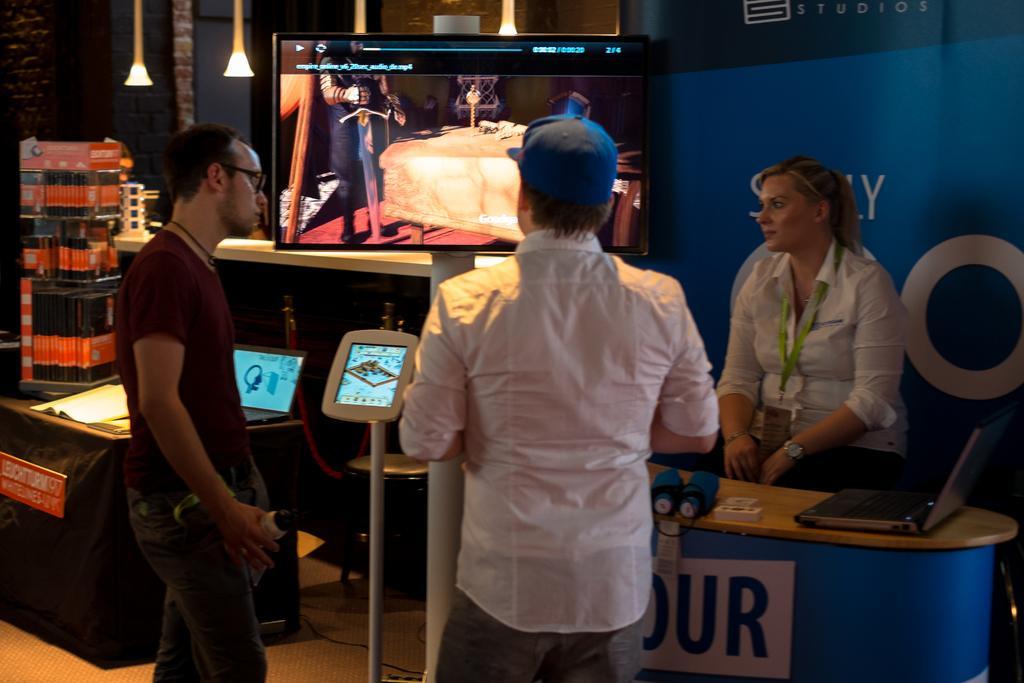In one or two sentences, can you explain what this image depicts? This is the picture taken in a room, there are three persons standing on a floor. In front of the people there is a television. Behind this people there is a banner. 